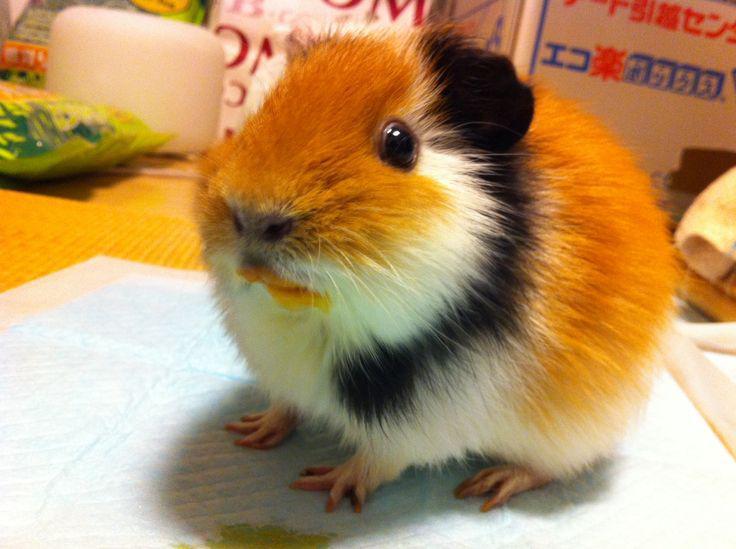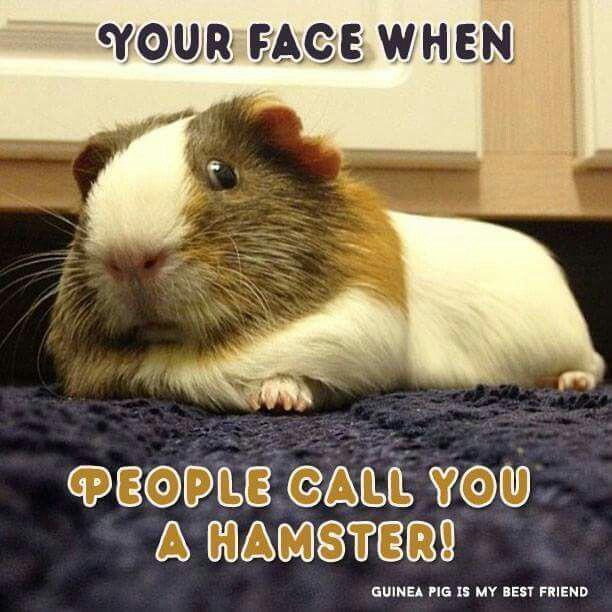The first image is the image on the left, the second image is the image on the right. Evaluate the accuracy of this statement regarding the images: "An image shows exactly four guinea pigs in a horizontal row.". Is it true? Answer yes or no. No. The first image is the image on the left, the second image is the image on the right. Examine the images to the left and right. Is the description "Four rodents sit in a row in one of the images." accurate? Answer yes or no. No. 